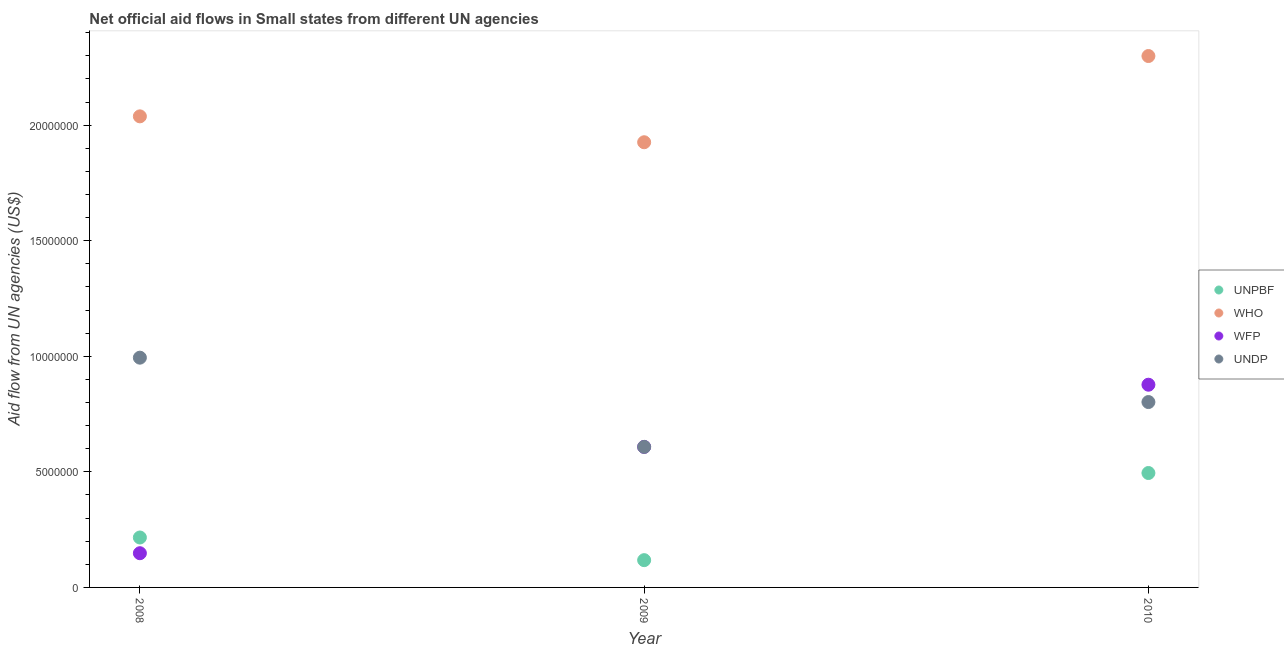How many different coloured dotlines are there?
Your answer should be compact. 4. What is the amount of aid given by who in 2008?
Offer a very short reply. 2.04e+07. Across all years, what is the maximum amount of aid given by who?
Give a very brief answer. 2.30e+07. Across all years, what is the minimum amount of aid given by wfp?
Provide a short and direct response. 1.48e+06. In which year was the amount of aid given by undp maximum?
Make the answer very short. 2008. In which year was the amount of aid given by unpbf minimum?
Keep it short and to the point. 2009. What is the total amount of aid given by undp in the graph?
Provide a succinct answer. 2.40e+07. What is the difference between the amount of aid given by who in 2008 and that in 2010?
Your response must be concise. -2.61e+06. What is the difference between the amount of aid given by unpbf in 2010 and the amount of aid given by wfp in 2009?
Your answer should be very brief. -1.13e+06. What is the average amount of aid given by undp per year?
Give a very brief answer. 8.01e+06. In the year 2010, what is the difference between the amount of aid given by unpbf and amount of aid given by who?
Keep it short and to the point. -1.80e+07. In how many years, is the amount of aid given by undp greater than 12000000 US$?
Offer a terse response. 0. What is the ratio of the amount of aid given by unpbf in 2009 to that in 2010?
Provide a short and direct response. 0.24. Is the amount of aid given by wfp in 2008 less than that in 2010?
Your answer should be compact. Yes. What is the difference between the highest and the second highest amount of aid given by wfp?
Provide a short and direct response. 2.69e+06. What is the difference between the highest and the lowest amount of aid given by who?
Make the answer very short. 3.73e+06. In how many years, is the amount of aid given by wfp greater than the average amount of aid given by wfp taken over all years?
Give a very brief answer. 2. Is it the case that in every year, the sum of the amount of aid given by unpbf and amount of aid given by who is greater than the amount of aid given by wfp?
Your response must be concise. Yes. Is the amount of aid given by unpbf strictly less than the amount of aid given by wfp over the years?
Provide a succinct answer. No. How many dotlines are there?
Provide a short and direct response. 4. How many years are there in the graph?
Ensure brevity in your answer.  3. What is the difference between two consecutive major ticks on the Y-axis?
Your answer should be compact. 5.00e+06. Are the values on the major ticks of Y-axis written in scientific E-notation?
Keep it short and to the point. No. Does the graph contain any zero values?
Ensure brevity in your answer.  No. Does the graph contain grids?
Make the answer very short. No. Where does the legend appear in the graph?
Provide a succinct answer. Center right. What is the title of the graph?
Your answer should be very brief. Net official aid flows in Small states from different UN agencies. Does "Austria" appear as one of the legend labels in the graph?
Offer a terse response. No. What is the label or title of the X-axis?
Your answer should be very brief. Year. What is the label or title of the Y-axis?
Your response must be concise. Aid flow from UN agencies (US$). What is the Aid flow from UN agencies (US$) in UNPBF in 2008?
Your answer should be compact. 2.16e+06. What is the Aid flow from UN agencies (US$) in WHO in 2008?
Offer a terse response. 2.04e+07. What is the Aid flow from UN agencies (US$) in WFP in 2008?
Your response must be concise. 1.48e+06. What is the Aid flow from UN agencies (US$) of UNDP in 2008?
Your response must be concise. 9.94e+06. What is the Aid flow from UN agencies (US$) of UNPBF in 2009?
Give a very brief answer. 1.18e+06. What is the Aid flow from UN agencies (US$) in WHO in 2009?
Provide a short and direct response. 1.93e+07. What is the Aid flow from UN agencies (US$) in WFP in 2009?
Give a very brief answer. 6.08e+06. What is the Aid flow from UN agencies (US$) of UNDP in 2009?
Provide a succinct answer. 6.08e+06. What is the Aid flow from UN agencies (US$) in UNPBF in 2010?
Ensure brevity in your answer.  4.95e+06. What is the Aid flow from UN agencies (US$) in WHO in 2010?
Provide a succinct answer. 2.30e+07. What is the Aid flow from UN agencies (US$) in WFP in 2010?
Your answer should be very brief. 8.77e+06. What is the Aid flow from UN agencies (US$) of UNDP in 2010?
Give a very brief answer. 8.02e+06. Across all years, what is the maximum Aid flow from UN agencies (US$) of UNPBF?
Offer a very short reply. 4.95e+06. Across all years, what is the maximum Aid flow from UN agencies (US$) of WHO?
Ensure brevity in your answer.  2.30e+07. Across all years, what is the maximum Aid flow from UN agencies (US$) of WFP?
Provide a succinct answer. 8.77e+06. Across all years, what is the maximum Aid flow from UN agencies (US$) in UNDP?
Provide a succinct answer. 9.94e+06. Across all years, what is the minimum Aid flow from UN agencies (US$) of UNPBF?
Provide a succinct answer. 1.18e+06. Across all years, what is the minimum Aid flow from UN agencies (US$) in WHO?
Your answer should be compact. 1.93e+07. Across all years, what is the minimum Aid flow from UN agencies (US$) of WFP?
Your answer should be very brief. 1.48e+06. Across all years, what is the minimum Aid flow from UN agencies (US$) of UNDP?
Make the answer very short. 6.08e+06. What is the total Aid flow from UN agencies (US$) in UNPBF in the graph?
Provide a short and direct response. 8.29e+06. What is the total Aid flow from UN agencies (US$) of WHO in the graph?
Provide a succinct answer. 6.26e+07. What is the total Aid flow from UN agencies (US$) of WFP in the graph?
Ensure brevity in your answer.  1.63e+07. What is the total Aid flow from UN agencies (US$) in UNDP in the graph?
Your answer should be very brief. 2.40e+07. What is the difference between the Aid flow from UN agencies (US$) in UNPBF in 2008 and that in 2009?
Your answer should be compact. 9.80e+05. What is the difference between the Aid flow from UN agencies (US$) in WHO in 2008 and that in 2009?
Give a very brief answer. 1.12e+06. What is the difference between the Aid flow from UN agencies (US$) of WFP in 2008 and that in 2009?
Your response must be concise. -4.60e+06. What is the difference between the Aid flow from UN agencies (US$) in UNDP in 2008 and that in 2009?
Give a very brief answer. 3.86e+06. What is the difference between the Aid flow from UN agencies (US$) in UNPBF in 2008 and that in 2010?
Ensure brevity in your answer.  -2.79e+06. What is the difference between the Aid flow from UN agencies (US$) in WHO in 2008 and that in 2010?
Provide a succinct answer. -2.61e+06. What is the difference between the Aid flow from UN agencies (US$) of WFP in 2008 and that in 2010?
Provide a succinct answer. -7.29e+06. What is the difference between the Aid flow from UN agencies (US$) of UNDP in 2008 and that in 2010?
Provide a short and direct response. 1.92e+06. What is the difference between the Aid flow from UN agencies (US$) in UNPBF in 2009 and that in 2010?
Offer a terse response. -3.77e+06. What is the difference between the Aid flow from UN agencies (US$) in WHO in 2009 and that in 2010?
Provide a succinct answer. -3.73e+06. What is the difference between the Aid flow from UN agencies (US$) in WFP in 2009 and that in 2010?
Your response must be concise. -2.69e+06. What is the difference between the Aid flow from UN agencies (US$) of UNDP in 2009 and that in 2010?
Provide a short and direct response. -1.94e+06. What is the difference between the Aid flow from UN agencies (US$) of UNPBF in 2008 and the Aid flow from UN agencies (US$) of WHO in 2009?
Give a very brief answer. -1.71e+07. What is the difference between the Aid flow from UN agencies (US$) in UNPBF in 2008 and the Aid flow from UN agencies (US$) in WFP in 2009?
Give a very brief answer. -3.92e+06. What is the difference between the Aid flow from UN agencies (US$) in UNPBF in 2008 and the Aid flow from UN agencies (US$) in UNDP in 2009?
Keep it short and to the point. -3.92e+06. What is the difference between the Aid flow from UN agencies (US$) in WHO in 2008 and the Aid flow from UN agencies (US$) in WFP in 2009?
Ensure brevity in your answer.  1.43e+07. What is the difference between the Aid flow from UN agencies (US$) of WHO in 2008 and the Aid flow from UN agencies (US$) of UNDP in 2009?
Give a very brief answer. 1.43e+07. What is the difference between the Aid flow from UN agencies (US$) of WFP in 2008 and the Aid flow from UN agencies (US$) of UNDP in 2009?
Provide a short and direct response. -4.60e+06. What is the difference between the Aid flow from UN agencies (US$) in UNPBF in 2008 and the Aid flow from UN agencies (US$) in WHO in 2010?
Your answer should be compact. -2.08e+07. What is the difference between the Aid flow from UN agencies (US$) in UNPBF in 2008 and the Aid flow from UN agencies (US$) in WFP in 2010?
Ensure brevity in your answer.  -6.61e+06. What is the difference between the Aid flow from UN agencies (US$) of UNPBF in 2008 and the Aid flow from UN agencies (US$) of UNDP in 2010?
Provide a short and direct response. -5.86e+06. What is the difference between the Aid flow from UN agencies (US$) in WHO in 2008 and the Aid flow from UN agencies (US$) in WFP in 2010?
Your answer should be compact. 1.16e+07. What is the difference between the Aid flow from UN agencies (US$) in WHO in 2008 and the Aid flow from UN agencies (US$) in UNDP in 2010?
Offer a terse response. 1.24e+07. What is the difference between the Aid flow from UN agencies (US$) of WFP in 2008 and the Aid flow from UN agencies (US$) of UNDP in 2010?
Your answer should be compact. -6.54e+06. What is the difference between the Aid flow from UN agencies (US$) of UNPBF in 2009 and the Aid flow from UN agencies (US$) of WHO in 2010?
Provide a short and direct response. -2.18e+07. What is the difference between the Aid flow from UN agencies (US$) in UNPBF in 2009 and the Aid flow from UN agencies (US$) in WFP in 2010?
Make the answer very short. -7.59e+06. What is the difference between the Aid flow from UN agencies (US$) of UNPBF in 2009 and the Aid flow from UN agencies (US$) of UNDP in 2010?
Provide a succinct answer. -6.84e+06. What is the difference between the Aid flow from UN agencies (US$) of WHO in 2009 and the Aid flow from UN agencies (US$) of WFP in 2010?
Provide a succinct answer. 1.05e+07. What is the difference between the Aid flow from UN agencies (US$) of WHO in 2009 and the Aid flow from UN agencies (US$) of UNDP in 2010?
Ensure brevity in your answer.  1.12e+07. What is the difference between the Aid flow from UN agencies (US$) in WFP in 2009 and the Aid flow from UN agencies (US$) in UNDP in 2010?
Provide a succinct answer. -1.94e+06. What is the average Aid flow from UN agencies (US$) in UNPBF per year?
Ensure brevity in your answer.  2.76e+06. What is the average Aid flow from UN agencies (US$) of WHO per year?
Your answer should be very brief. 2.09e+07. What is the average Aid flow from UN agencies (US$) in WFP per year?
Make the answer very short. 5.44e+06. What is the average Aid flow from UN agencies (US$) of UNDP per year?
Keep it short and to the point. 8.01e+06. In the year 2008, what is the difference between the Aid flow from UN agencies (US$) of UNPBF and Aid flow from UN agencies (US$) of WHO?
Your answer should be compact. -1.82e+07. In the year 2008, what is the difference between the Aid flow from UN agencies (US$) of UNPBF and Aid flow from UN agencies (US$) of WFP?
Ensure brevity in your answer.  6.80e+05. In the year 2008, what is the difference between the Aid flow from UN agencies (US$) in UNPBF and Aid flow from UN agencies (US$) in UNDP?
Your answer should be very brief. -7.78e+06. In the year 2008, what is the difference between the Aid flow from UN agencies (US$) in WHO and Aid flow from UN agencies (US$) in WFP?
Your response must be concise. 1.89e+07. In the year 2008, what is the difference between the Aid flow from UN agencies (US$) in WHO and Aid flow from UN agencies (US$) in UNDP?
Ensure brevity in your answer.  1.04e+07. In the year 2008, what is the difference between the Aid flow from UN agencies (US$) in WFP and Aid flow from UN agencies (US$) in UNDP?
Offer a terse response. -8.46e+06. In the year 2009, what is the difference between the Aid flow from UN agencies (US$) in UNPBF and Aid flow from UN agencies (US$) in WHO?
Offer a very short reply. -1.81e+07. In the year 2009, what is the difference between the Aid flow from UN agencies (US$) in UNPBF and Aid flow from UN agencies (US$) in WFP?
Ensure brevity in your answer.  -4.90e+06. In the year 2009, what is the difference between the Aid flow from UN agencies (US$) in UNPBF and Aid flow from UN agencies (US$) in UNDP?
Make the answer very short. -4.90e+06. In the year 2009, what is the difference between the Aid flow from UN agencies (US$) in WHO and Aid flow from UN agencies (US$) in WFP?
Provide a succinct answer. 1.32e+07. In the year 2009, what is the difference between the Aid flow from UN agencies (US$) in WHO and Aid flow from UN agencies (US$) in UNDP?
Give a very brief answer. 1.32e+07. In the year 2010, what is the difference between the Aid flow from UN agencies (US$) of UNPBF and Aid flow from UN agencies (US$) of WHO?
Give a very brief answer. -1.80e+07. In the year 2010, what is the difference between the Aid flow from UN agencies (US$) of UNPBF and Aid flow from UN agencies (US$) of WFP?
Your response must be concise. -3.82e+06. In the year 2010, what is the difference between the Aid flow from UN agencies (US$) of UNPBF and Aid flow from UN agencies (US$) of UNDP?
Make the answer very short. -3.07e+06. In the year 2010, what is the difference between the Aid flow from UN agencies (US$) in WHO and Aid flow from UN agencies (US$) in WFP?
Offer a terse response. 1.42e+07. In the year 2010, what is the difference between the Aid flow from UN agencies (US$) in WHO and Aid flow from UN agencies (US$) in UNDP?
Provide a succinct answer. 1.50e+07. In the year 2010, what is the difference between the Aid flow from UN agencies (US$) in WFP and Aid flow from UN agencies (US$) in UNDP?
Your response must be concise. 7.50e+05. What is the ratio of the Aid flow from UN agencies (US$) of UNPBF in 2008 to that in 2009?
Your answer should be very brief. 1.83. What is the ratio of the Aid flow from UN agencies (US$) in WHO in 2008 to that in 2009?
Make the answer very short. 1.06. What is the ratio of the Aid flow from UN agencies (US$) of WFP in 2008 to that in 2009?
Provide a short and direct response. 0.24. What is the ratio of the Aid flow from UN agencies (US$) of UNDP in 2008 to that in 2009?
Your answer should be very brief. 1.63. What is the ratio of the Aid flow from UN agencies (US$) in UNPBF in 2008 to that in 2010?
Provide a short and direct response. 0.44. What is the ratio of the Aid flow from UN agencies (US$) of WHO in 2008 to that in 2010?
Your answer should be compact. 0.89. What is the ratio of the Aid flow from UN agencies (US$) in WFP in 2008 to that in 2010?
Make the answer very short. 0.17. What is the ratio of the Aid flow from UN agencies (US$) of UNDP in 2008 to that in 2010?
Your answer should be compact. 1.24. What is the ratio of the Aid flow from UN agencies (US$) of UNPBF in 2009 to that in 2010?
Provide a short and direct response. 0.24. What is the ratio of the Aid flow from UN agencies (US$) in WHO in 2009 to that in 2010?
Provide a short and direct response. 0.84. What is the ratio of the Aid flow from UN agencies (US$) of WFP in 2009 to that in 2010?
Ensure brevity in your answer.  0.69. What is the ratio of the Aid flow from UN agencies (US$) of UNDP in 2009 to that in 2010?
Your response must be concise. 0.76. What is the difference between the highest and the second highest Aid flow from UN agencies (US$) in UNPBF?
Offer a very short reply. 2.79e+06. What is the difference between the highest and the second highest Aid flow from UN agencies (US$) in WHO?
Give a very brief answer. 2.61e+06. What is the difference between the highest and the second highest Aid flow from UN agencies (US$) of WFP?
Keep it short and to the point. 2.69e+06. What is the difference between the highest and the second highest Aid flow from UN agencies (US$) in UNDP?
Provide a short and direct response. 1.92e+06. What is the difference between the highest and the lowest Aid flow from UN agencies (US$) in UNPBF?
Make the answer very short. 3.77e+06. What is the difference between the highest and the lowest Aid flow from UN agencies (US$) in WHO?
Offer a very short reply. 3.73e+06. What is the difference between the highest and the lowest Aid flow from UN agencies (US$) in WFP?
Your answer should be very brief. 7.29e+06. What is the difference between the highest and the lowest Aid flow from UN agencies (US$) in UNDP?
Provide a succinct answer. 3.86e+06. 